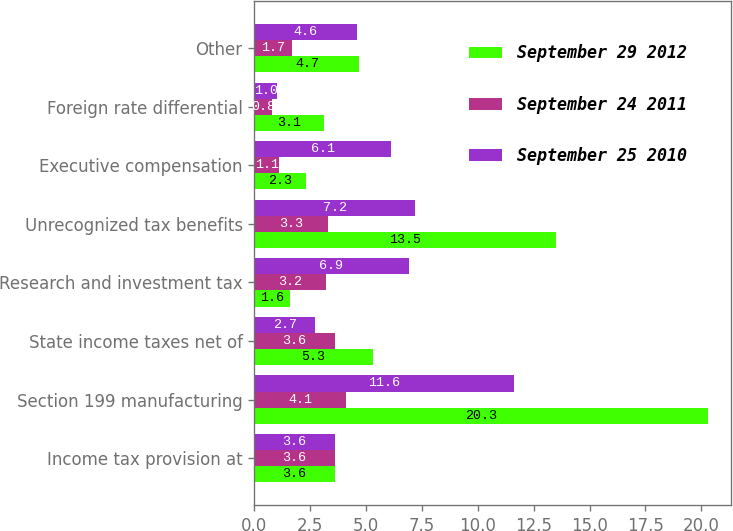<chart> <loc_0><loc_0><loc_500><loc_500><stacked_bar_chart><ecel><fcel>Income tax provision at<fcel>Section 199 manufacturing<fcel>State income taxes net of<fcel>Research and investment tax<fcel>Unrecognized tax benefits<fcel>Executive compensation<fcel>Foreign rate differential<fcel>Other<nl><fcel>September 29 2012<fcel>3.6<fcel>20.3<fcel>5.3<fcel>1.6<fcel>13.5<fcel>2.3<fcel>3.1<fcel>4.7<nl><fcel>September 24 2011<fcel>3.6<fcel>4.1<fcel>3.6<fcel>3.2<fcel>3.3<fcel>1.1<fcel>0.8<fcel>1.7<nl><fcel>September 25 2010<fcel>3.6<fcel>11.6<fcel>2.7<fcel>6.9<fcel>7.2<fcel>6.1<fcel>1<fcel>4.6<nl></chart> 